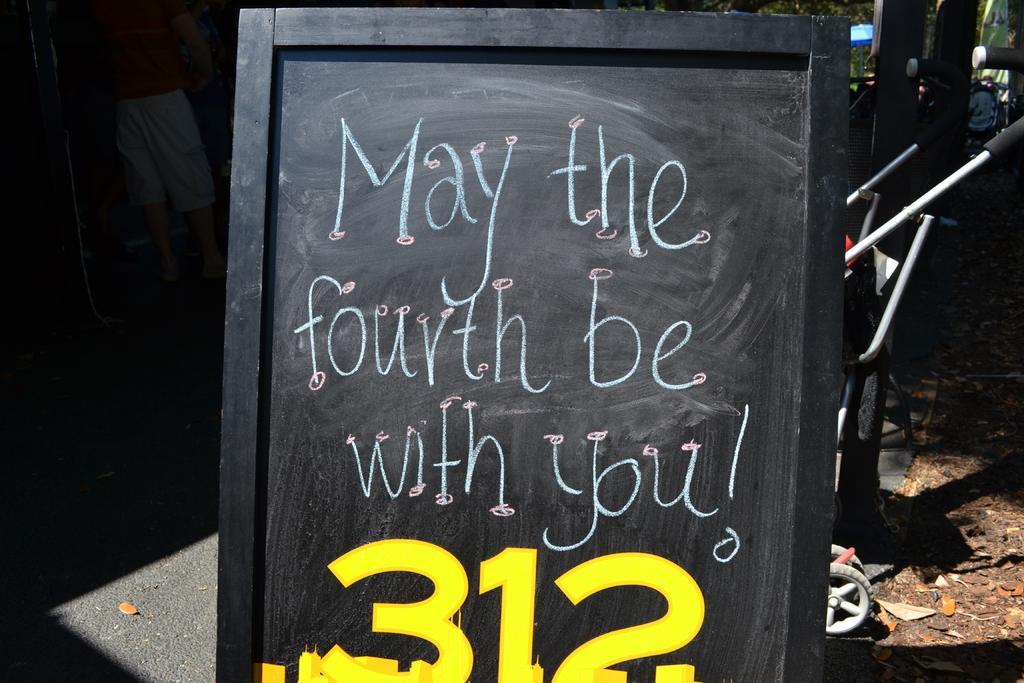In one or two sentences, can you explain what this image depicts? In the center of the image, we can see a board with some text and numbers and in the background, there are stands and we can see trees. At the bottom, there is ground and there is a person standing on the road. 